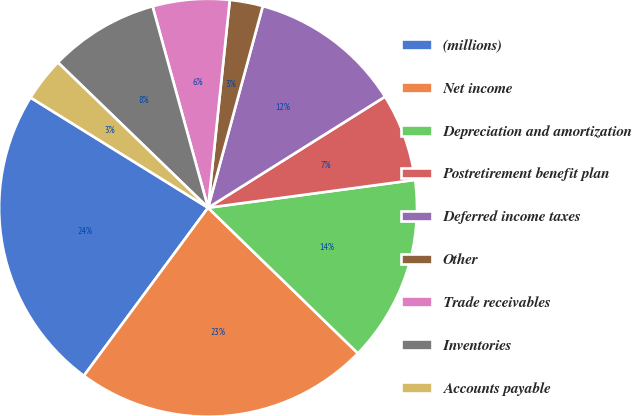Convert chart to OTSL. <chart><loc_0><loc_0><loc_500><loc_500><pie_chart><fcel>(millions)<fcel>Net income<fcel>Depreciation and amortization<fcel>Postretirement benefit plan<fcel>Deferred income taxes<fcel>Other<fcel>Trade receivables<fcel>Inventories<fcel>Accounts payable<nl><fcel>23.71%<fcel>22.86%<fcel>14.4%<fcel>6.79%<fcel>11.86%<fcel>2.56%<fcel>5.94%<fcel>8.48%<fcel>3.4%<nl></chart> 